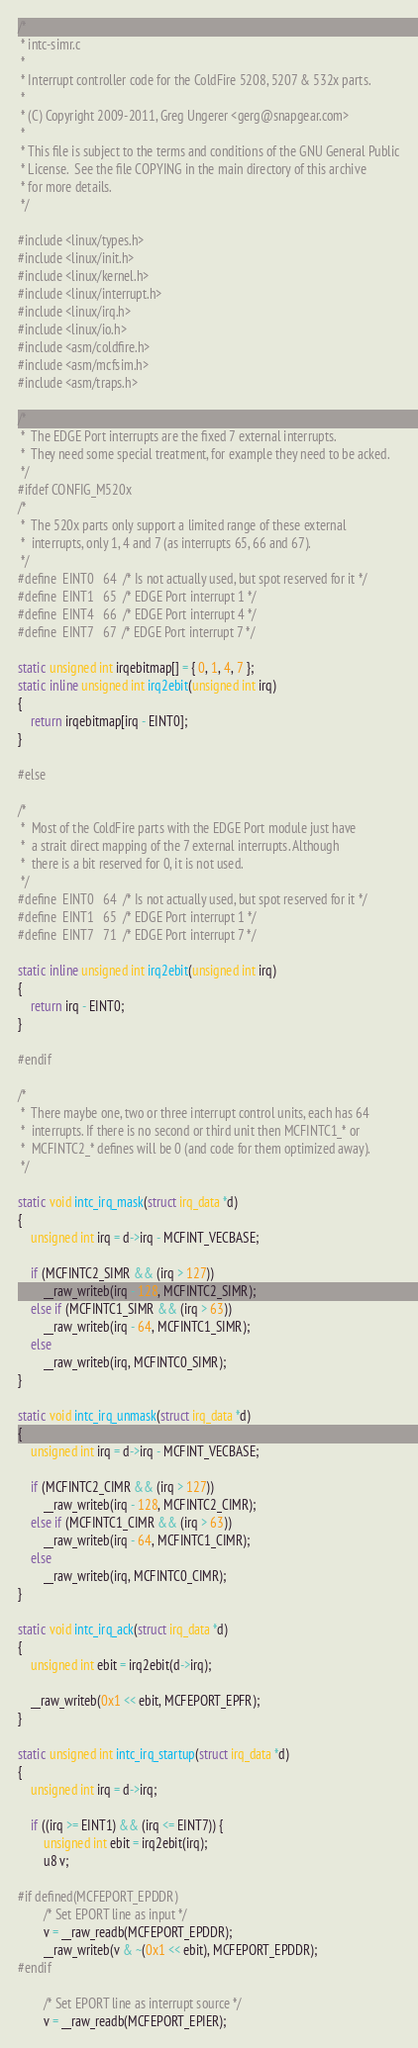Convert code to text. <code><loc_0><loc_0><loc_500><loc_500><_C_>/*
 * intc-simr.c
 *
 * Interrupt controller code for the ColdFire 5208, 5207 & 532x parts.
 *
 * (C) Copyright 2009-2011, Greg Ungerer <gerg@snapgear.com>
 *
 * This file is subject to the terms and conditions of the GNU General Public
 * License.  See the file COPYING in the main directory of this archive
 * for more details.
 */

#include <linux/types.h>
#include <linux/init.h>
#include <linux/kernel.h>
#include <linux/interrupt.h>
#include <linux/irq.h>
#include <linux/io.h>
#include <asm/coldfire.h>
#include <asm/mcfsim.h>
#include <asm/traps.h>

/*
 *	The EDGE Port interrupts are the fixed 7 external interrupts.
 *	They need some special treatment, for example they need to be acked.
 */
#ifdef CONFIG_M520x
/*
 *	The 520x parts only support a limited range of these external
 *	interrupts, only 1, 4 and 7 (as interrupts 65, 66 and 67).
 */
#define	EINT0	64	/* Is not actually used, but spot reserved for it */
#define	EINT1	65	/* EDGE Port interrupt 1 */
#define	EINT4	66	/* EDGE Port interrupt 4 */
#define	EINT7	67	/* EDGE Port interrupt 7 */

static unsigned int irqebitmap[] = { 0, 1, 4, 7 };
static inline unsigned int irq2ebit(unsigned int irq)
{
	return irqebitmap[irq - EINT0];
}

#else

/*
 *	Most of the ColdFire parts with the EDGE Port module just have
 *	a strait direct mapping of the 7 external interrupts. Although
 *	there is a bit reserved for 0, it is not used.
 */
#define	EINT0	64	/* Is not actually used, but spot reserved for it */
#define	EINT1	65	/* EDGE Port interrupt 1 */
#define	EINT7	71	/* EDGE Port interrupt 7 */

static inline unsigned int irq2ebit(unsigned int irq)
{
	return irq - EINT0;
}

#endif

/*
 *	There maybe one, two or three interrupt control units, each has 64
 *	interrupts. If there is no second or third unit then MCFINTC1_* or
 *	MCFINTC2_* defines will be 0 (and code for them optimized away).
 */

static void intc_irq_mask(struct irq_data *d)
{
	unsigned int irq = d->irq - MCFINT_VECBASE;

	if (MCFINTC2_SIMR && (irq > 127))
		__raw_writeb(irq - 128, MCFINTC2_SIMR);
	else if (MCFINTC1_SIMR && (irq > 63))
		__raw_writeb(irq - 64, MCFINTC1_SIMR);
	else
		__raw_writeb(irq, MCFINTC0_SIMR);
}

static void intc_irq_unmask(struct irq_data *d)
{
	unsigned int irq = d->irq - MCFINT_VECBASE;

	if (MCFINTC2_CIMR && (irq > 127))
		__raw_writeb(irq - 128, MCFINTC2_CIMR);
	else if (MCFINTC1_CIMR && (irq > 63))
		__raw_writeb(irq - 64, MCFINTC1_CIMR);
	else
		__raw_writeb(irq, MCFINTC0_CIMR);
}

static void intc_irq_ack(struct irq_data *d)
{
	unsigned int ebit = irq2ebit(d->irq);

	__raw_writeb(0x1 << ebit, MCFEPORT_EPFR);
}

static unsigned int intc_irq_startup(struct irq_data *d)
{
	unsigned int irq = d->irq;

	if ((irq >= EINT1) && (irq <= EINT7)) {
		unsigned int ebit = irq2ebit(irq);
		u8 v;

#if defined(MCFEPORT_EPDDR)
		/* Set EPORT line as input */
		v = __raw_readb(MCFEPORT_EPDDR);
		__raw_writeb(v & ~(0x1 << ebit), MCFEPORT_EPDDR);
#endif

		/* Set EPORT line as interrupt source */
		v = __raw_readb(MCFEPORT_EPIER);</code> 